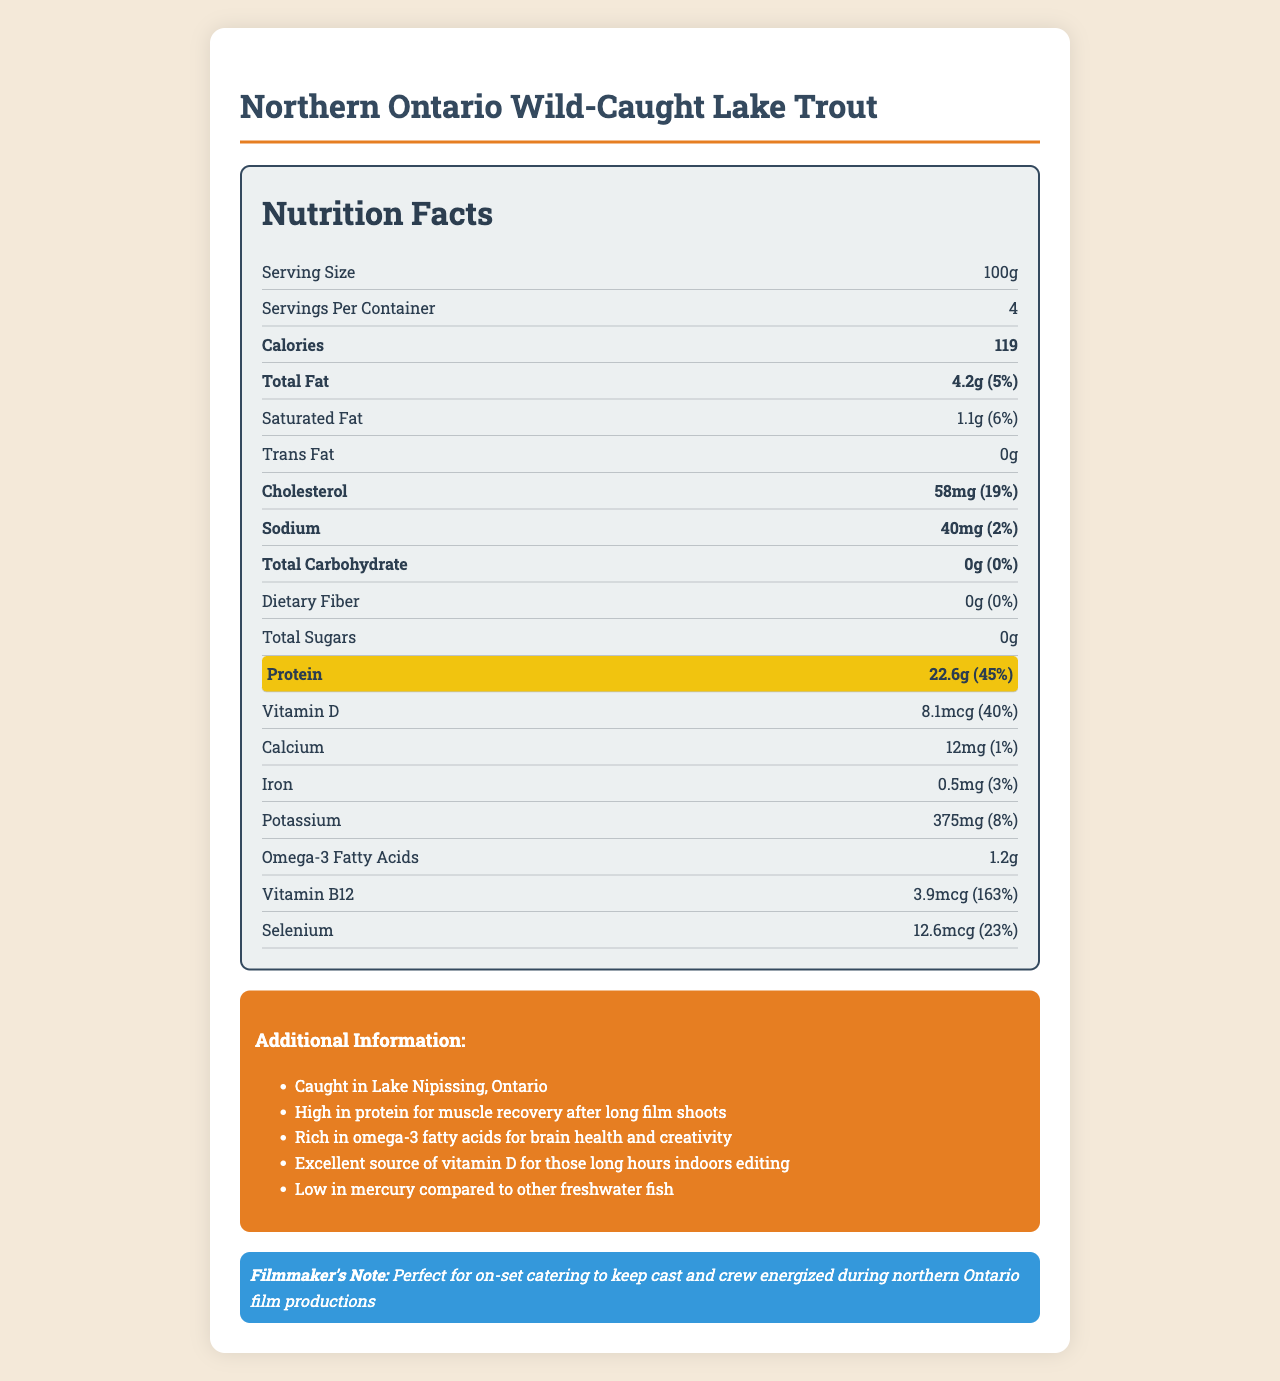what is the serving size? The serving size is listed in the document as "Serving Size: 100g".
Answer: 100g how much protein is in one serving? The document states in the highlighted section that protein content is 22.6g per serving.
Answer: 22.6g what percentage of daily value does the protein content cover? The document indicates that 22.6g of protein covers 45% of the daily value.
Answer: 45% how many calories are in one serving? The document lists the calorie content per serving as 119 calories.
Answer: 119 calories what is the amount of omega-3 fatty acids per serving? The document mentions that the amount of omega-3 fatty acids per serving is 1.2g.
Answer: 1.2g how many servings are there per container? The document specifies under "Servings Per Container" that there are 4 servings per container.
Answer: 4 what is the total fat content per serving? A. 2.1g B. 3.5g C. 4.2g D. 5.0g The document states that the total fat content per serving is 4.2g.
Answer: C. 4.2g How much vitamin B12 does each serving provide?
A. 1.2mcg
B. 2.4mcg
C. 3.9mcg
D. 5.2mcg The document states that each serving provides 3.9mcg of vitamin B12.
Answer: C. 3.9mcg does the lake trout contain any trans fat? The document indicates that the amount of trans fat is 0g, implying there is no trans fat.
Answer: No describe the main idea of the document. The document provides an overview of the nutritional content per serving of lake trout, along with additional information about its benefits, especially for film productions in northeastern Ontario.
Answer: The document is a detailed nutrition facts label for Northern Ontario Wild-Caught Lake Trout, highlighting its high protein content and other nutritional benefits. It emphasizes its suitability for on-set catering due to its high protein and nutritional value essential for film crews. what is the source of the lake trout? The document under "Additional Information" mentions that the lake trout is caught in Lake Nipissing, Ontario.
Answer: Lake Nipissing, Ontario how much cholesterol does one serving contain? The document states that one serving contains 58mg of cholesterol.
Answer: 58mg can we determine the price of the lake trout from this document? The document does not provide any information about the price of the lake trout.
Answer: Cannot be determined what is the amount of dietary fiber per serving? The document specifies that the amount of dietary fiber per serving is 0g.
Answer: 0g which nutrient has the highest daily value percentage? A. Vitamin D B. Selenium C. Protein D. Vitamin B12 The document shows that Vitamin B12 has a daily value percentage of 163%, which is the highest among the listed nutrients.
Answer: D. Vitamin B12 